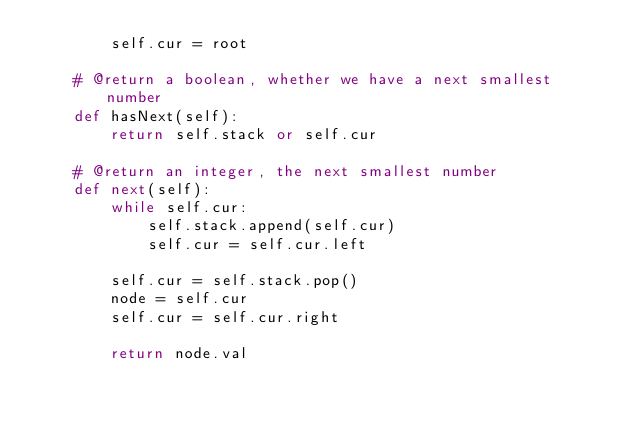Convert code to text. <code><loc_0><loc_0><loc_500><loc_500><_Python_>        self.cur = root

    # @return a boolean, whether we have a next smallest number
    def hasNext(self):
        return self.stack or self.cur

    # @return an integer, the next smallest number
    def next(self):
        while self.cur:
            self.stack.append(self.cur)
            self.cur = self.cur.left

        self.cur = self.stack.pop()
        node = self.cur
        self.cur = self.cur.right

        return node.val

</code> 